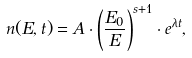<formula> <loc_0><loc_0><loc_500><loc_500>n ( E , t ) = A \cdot \left ( \frac { E _ { 0 } } { E } \right ) ^ { s + 1 } \cdot e ^ { \lambda t } ,</formula> 